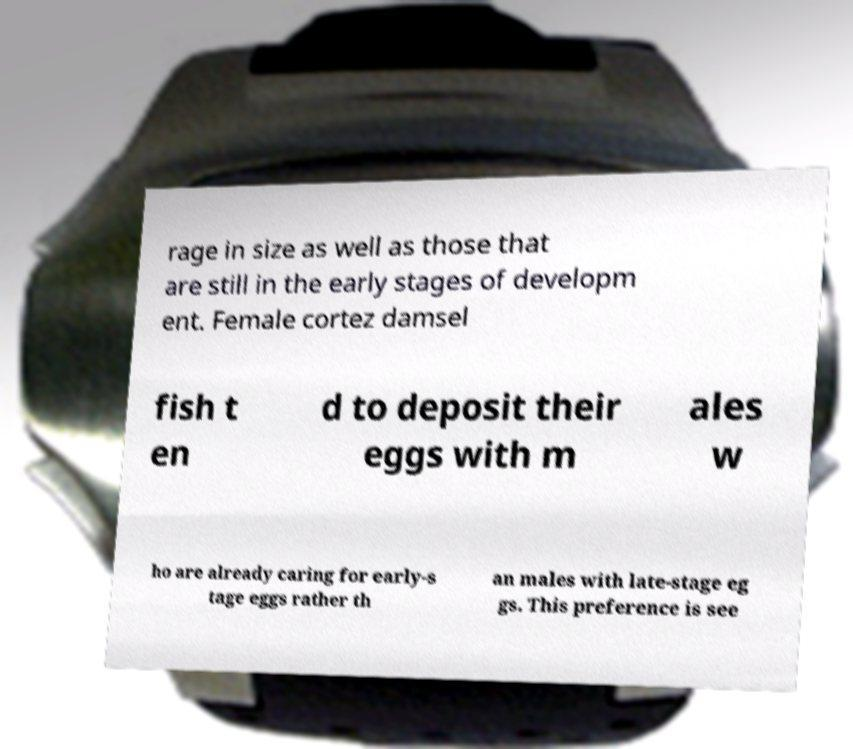Please read and relay the text visible in this image. What does it say? rage in size as well as those that are still in the early stages of developm ent. Female cortez damsel fish t en d to deposit their eggs with m ales w ho are already caring for early-s tage eggs rather th an males with late-stage eg gs. This preference is see 